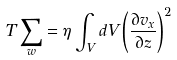<formula> <loc_0><loc_0><loc_500><loc_500>T \sum _ { w } = \eta \int _ { V } d V \left ( \frac { \partial v _ { x } } { \partial z } \right ) ^ { 2 }</formula> 